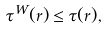Convert formula to latex. <formula><loc_0><loc_0><loc_500><loc_500>\tau ^ { W } ( r ) \leq \tau ( r ) ,</formula> 